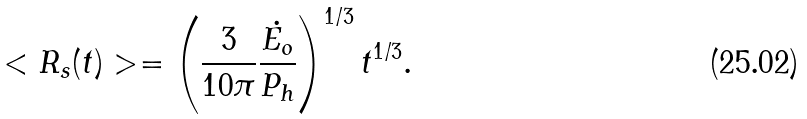<formula> <loc_0><loc_0><loc_500><loc_500>< R _ { s } ( t ) > = \left ( \frac { 3 } { 1 0 \pi } \frac { \dot { E _ { o } } } { P _ { h } } \right ) ^ { 1 / 3 } t ^ { 1 / 3 } .</formula> 